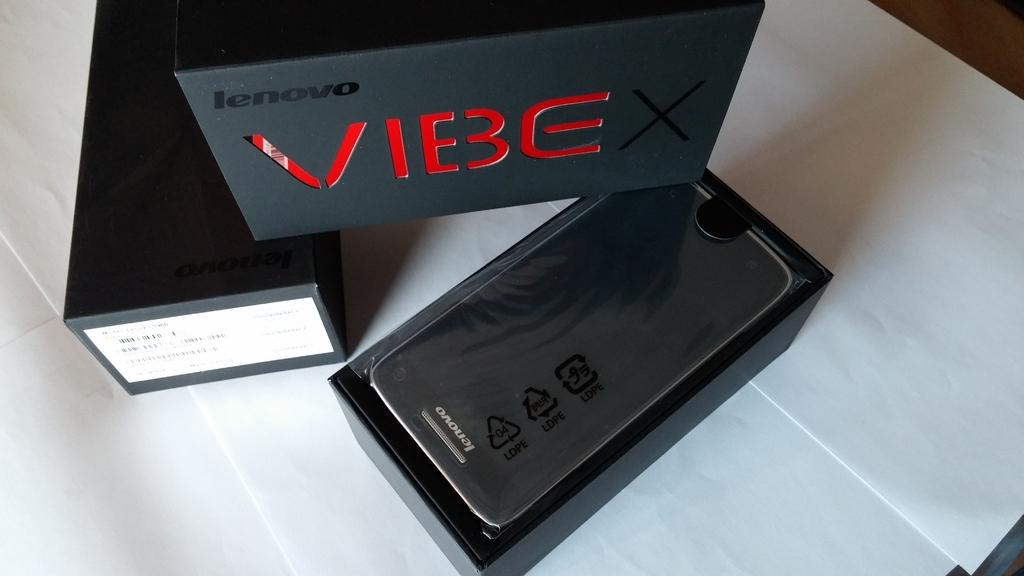Provide a one-sentence caption for the provided image. A lenovo Vibe smartphone in the original box. 